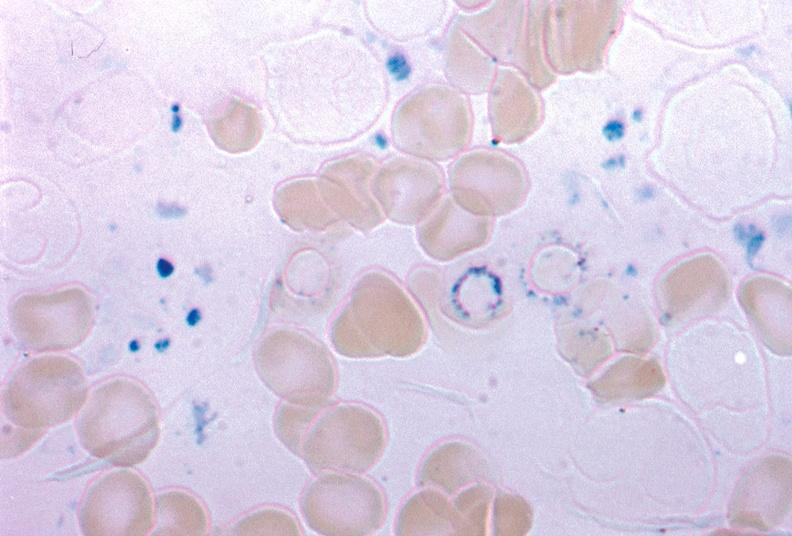s palmar crease normal present?
Answer the question using a single word or phrase. No 